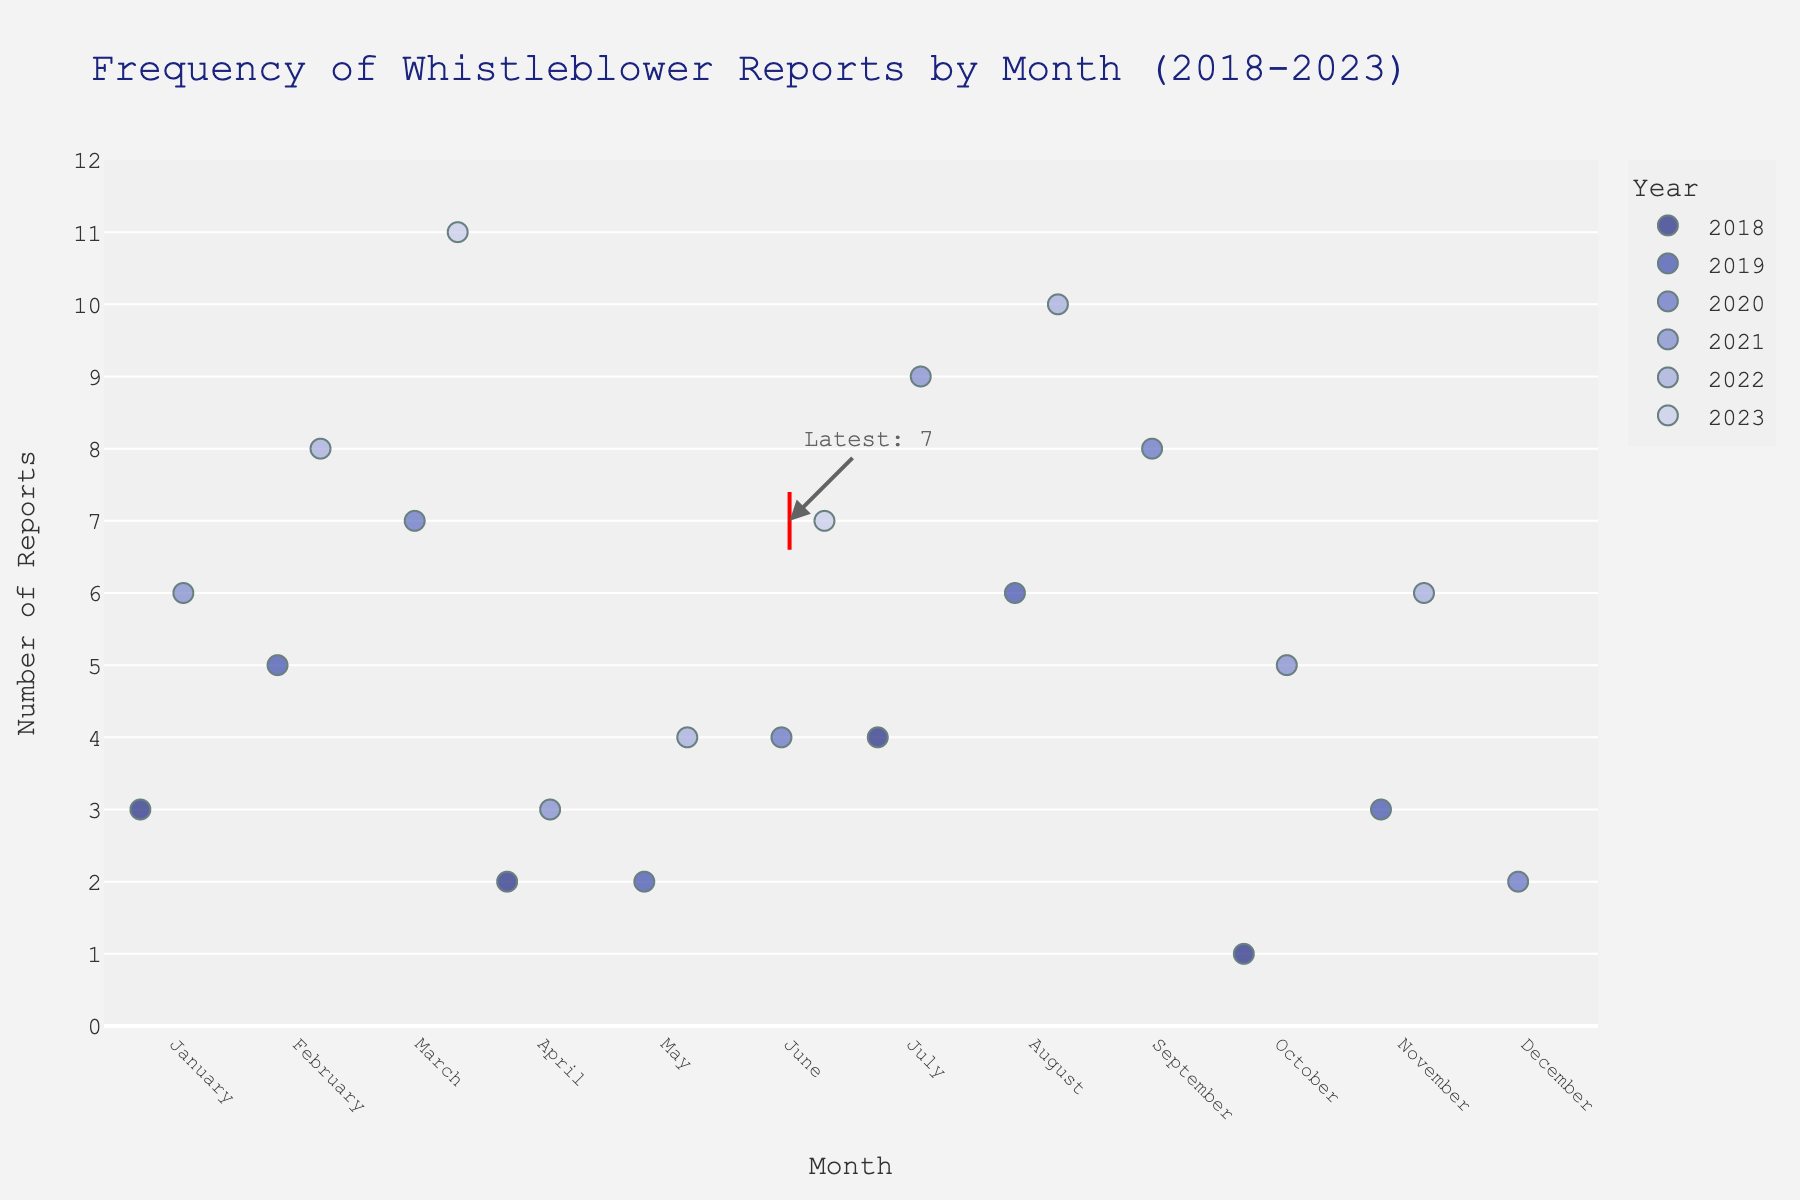What is the title of the plot? The title is displayed at the top of the plot in a larger font size and centered alignment.
Answer: Frequency of Whistleblower Reports by Month (2018-2023) Which month in 2020 had the highest number of reports? Identify the year 2020 and compare all the plot points for that year. March has the highest y-value.
Answer: March How many reports were there in October 2018? Locate October 2018 by finding the '2018' category in the color legend and identifying the dot for October. The y-axis value is 1.
Answer: 1 What is the trend in the number of reports from January to December 2022? Track all dots for the year 2022 in chronological order and note their y-values: 8, 4, 10, and 6. The number fluctuates but peaks in August.
Answer: Fluctuating, peaking in August Which year had the month with the highest number of reports? Look for the dot with the highest y-value, which represents 11 reports, and note its color and legend. This dot corresponds to March 2023.
Answer: 2023 On average, how many reports were filed in the months of May over the 5 years? Sum the reports for May (2, 2, 4) and divide by 3 (number of Mays): (2 + 2 + 4) / 3 = 2.67.
Answer: 2.67 What is the median number of reports filed in March over the years? Identify March's data points and list them in order: 7, 11. In this case, the median value is between the two values, so (7 + 11) / 2 = 9.
Answer: 9 Is there a significant increase or decrease in reports from June to July in any year? Compare June to July for each year. For instance, 2021 shows an increase from 6 to 9 reports.
Answer: Increase in 2021 In which month and year does the highlighted/latest data point occur? Locate the red highlighted rectangle marking the latest data. It appears in March 2023.
Answer: March 2023 